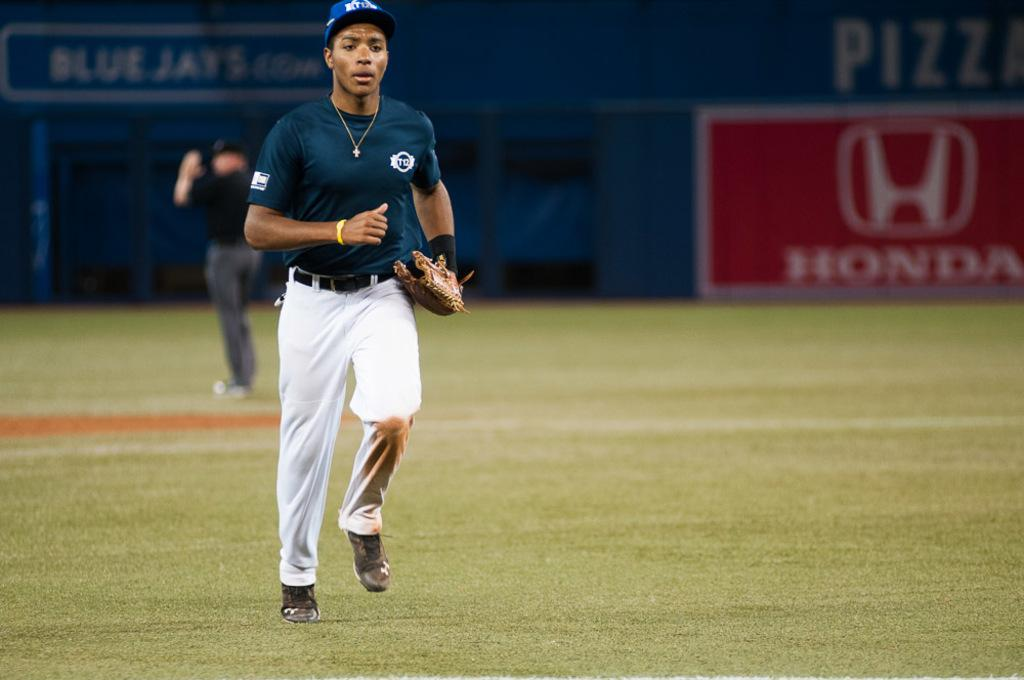<image>
Summarize the visual content of the image. A player runs on the field at a Blue Jays baseball game. 